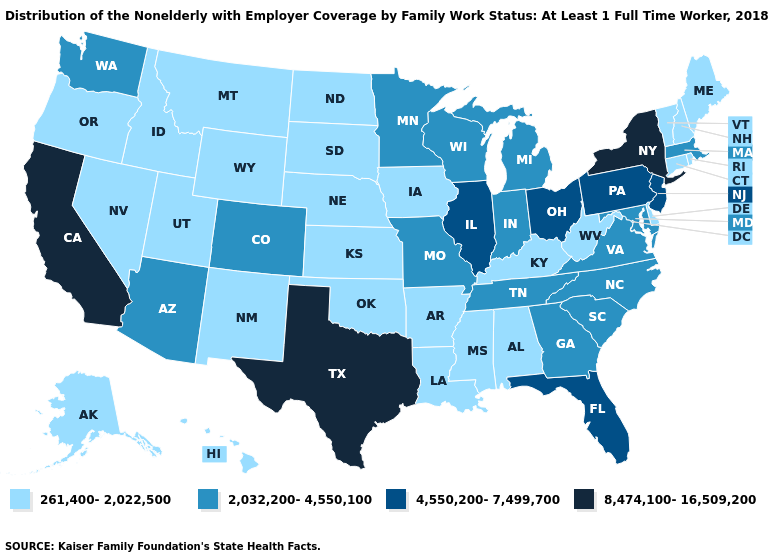Which states have the lowest value in the USA?
Short answer required. Alabama, Alaska, Arkansas, Connecticut, Delaware, Hawaii, Idaho, Iowa, Kansas, Kentucky, Louisiana, Maine, Mississippi, Montana, Nebraska, Nevada, New Hampshire, New Mexico, North Dakota, Oklahoma, Oregon, Rhode Island, South Dakota, Utah, Vermont, West Virginia, Wyoming. Does Rhode Island have the same value as Alabama?
Keep it brief. Yes. Name the states that have a value in the range 261,400-2,022,500?
Write a very short answer. Alabama, Alaska, Arkansas, Connecticut, Delaware, Hawaii, Idaho, Iowa, Kansas, Kentucky, Louisiana, Maine, Mississippi, Montana, Nebraska, Nevada, New Hampshire, New Mexico, North Dakota, Oklahoma, Oregon, Rhode Island, South Dakota, Utah, Vermont, West Virginia, Wyoming. Among the states that border Illinois , which have the lowest value?
Write a very short answer. Iowa, Kentucky. What is the value of Connecticut?
Give a very brief answer. 261,400-2,022,500. Name the states that have a value in the range 2,032,200-4,550,100?
Concise answer only. Arizona, Colorado, Georgia, Indiana, Maryland, Massachusetts, Michigan, Minnesota, Missouri, North Carolina, South Carolina, Tennessee, Virginia, Washington, Wisconsin. What is the value of Wisconsin?
Write a very short answer. 2,032,200-4,550,100. Does Kentucky have the lowest value in the South?
Quick response, please. Yes. How many symbols are there in the legend?
Give a very brief answer. 4. Name the states that have a value in the range 2,032,200-4,550,100?
Concise answer only. Arizona, Colorado, Georgia, Indiana, Maryland, Massachusetts, Michigan, Minnesota, Missouri, North Carolina, South Carolina, Tennessee, Virginia, Washington, Wisconsin. What is the lowest value in the Northeast?
Quick response, please. 261,400-2,022,500. Name the states that have a value in the range 2,032,200-4,550,100?
Be succinct. Arizona, Colorado, Georgia, Indiana, Maryland, Massachusetts, Michigan, Minnesota, Missouri, North Carolina, South Carolina, Tennessee, Virginia, Washington, Wisconsin. Does the map have missing data?
Write a very short answer. No. Which states hav the highest value in the West?
Short answer required. California. 